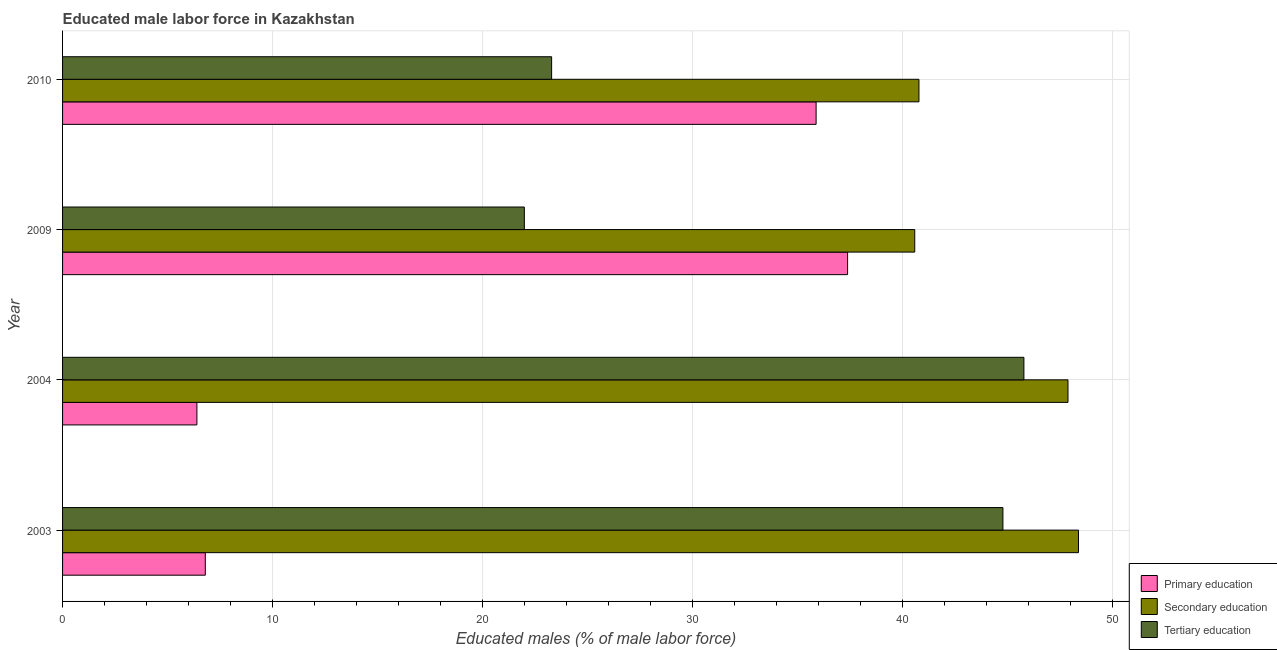How many different coloured bars are there?
Provide a short and direct response. 3. How many bars are there on the 3rd tick from the top?
Your response must be concise. 3. What is the label of the 4th group of bars from the top?
Make the answer very short. 2003. In how many cases, is the number of bars for a given year not equal to the number of legend labels?
Provide a short and direct response. 0. What is the percentage of male labor force who received secondary education in 2009?
Provide a short and direct response. 40.6. Across all years, what is the maximum percentage of male labor force who received secondary education?
Provide a short and direct response. 48.4. Across all years, what is the minimum percentage of male labor force who received primary education?
Offer a terse response. 6.4. In which year was the percentage of male labor force who received secondary education maximum?
Provide a succinct answer. 2003. What is the total percentage of male labor force who received tertiary education in the graph?
Offer a terse response. 135.9. What is the difference between the percentage of male labor force who received primary education in 2009 and that in 2010?
Make the answer very short. 1.5. What is the difference between the percentage of male labor force who received secondary education in 2004 and the percentage of male labor force who received tertiary education in 2009?
Ensure brevity in your answer.  25.9. What is the average percentage of male labor force who received secondary education per year?
Offer a terse response. 44.42. In the year 2009, what is the difference between the percentage of male labor force who received tertiary education and percentage of male labor force who received secondary education?
Keep it short and to the point. -18.6. In how many years, is the percentage of male labor force who received primary education greater than 8 %?
Offer a very short reply. 2. What is the ratio of the percentage of male labor force who received secondary education in 2004 to that in 2009?
Your answer should be very brief. 1.18. Is the percentage of male labor force who received secondary education in 2004 less than that in 2010?
Make the answer very short. No. What is the difference between the highest and the second highest percentage of male labor force who received secondary education?
Give a very brief answer. 0.5. What is the difference between the highest and the lowest percentage of male labor force who received tertiary education?
Your response must be concise. 23.8. What does the 2nd bar from the top in 2010 represents?
Provide a short and direct response. Secondary education. What does the 2nd bar from the bottom in 2004 represents?
Make the answer very short. Secondary education. Is it the case that in every year, the sum of the percentage of male labor force who received primary education and percentage of male labor force who received secondary education is greater than the percentage of male labor force who received tertiary education?
Provide a succinct answer. Yes. How many bars are there?
Offer a very short reply. 12. Are the values on the major ticks of X-axis written in scientific E-notation?
Your response must be concise. No. Where does the legend appear in the graph?
Provide a short and direct response. Bottom right. What is the title of the graph?
Keep it short and to the point. Educated male labor force in Kazakhstan. Does "Taxes on goods and services" appear as one of the legend labels in the graph?
Ensure brevity in your answer.  No. What is the label or title of the X-axis?
Your answer should be compact. Educated males (% of male labor force). What is the label or title of the Y-axis?
Your answer should be compact. Year. What is the Educated males (% of male labor force) in Primary education in 2003?
Offer a very short reply. 6.8. What is the Educated males (% of male labor force) of Secondary education in 2003?
Your answer should be compact. 48.4. What is the Educated males (% of male labor force) of Tertiary education in 2003?
Provide a short and direct response. 44.8. What is the Educated males (% of male labor force) of Primary education in 2004?
Keep it short and to the point. 6.4. What is the Educated males (% of male labor force) of Secondary education in 2004?
Offer a very short reply. 47.9. What is the Educated males (% of male labor force) of Tertiary education in 2004?
Make the answer very short. 45.8. What is the Educated males (% of male labor force) in Primary education in 2009?
Provide a succinct answer. 37.4. What is the Educated males (% of male labor force) of Secondary education in 2009?
Provide a succinct answer. 40.6. What is the Educated males (% of male labor force) of Tertiary education in 2009?
Provide a succinct answer. 22. What is the Educated males (% of male labor force) in Primary education in 2010?
Ensure brevity in your answer.  35.9. What is the Educated males (% of male labor force) in Secondary education in 2010?
Make the answer very short. 40.8. What is the Educated males (% of male labor force) in Tertiary education in 2010?
Give a very brief answer. 23.3. Across all years, what is the maximum Educated males (% of male labor force) of Primary education?
Provide a short and direct response. 37.4. Across all years, what is the maximum Educated males (% of male labor force) of Secondary education?
Offer a very short reply. 48.4. Across all years, what is the maximum Educated males (% of male labor force) in Tertiary education?
Your response must be concise. 45.8. Across all years, what is the minimum Educated males (% of male labor force) of Primary education?
Your answer should be very brief. 6.4. Across all years, what is the minimum Educated males (% of male labor force) of Secondary education?
Provide a succinct answer. 40.6. Across all years, what is the minimum Educated males (% of male labor force) in Tertiary education?
Provide a succinct answer. 22. What is the total Educated males (% of male labor force) of Primary education in the graph?
Provide a succinct answer. 86.5. What is the total Educated males (% of male labor force) of Secondary education in the graph?
Your response must be concise. 177.7. What is the total Educated males (% of male labor force) of Tertiary education in the graph?
Ensure brevity in your answer.  135.9. What is the difference between the Educated males (% of male labor force) in Secondary education in 2003 and that in 2004?
Your answer should be compact. 0.5. What is the difference between the Educated males (% of male labor force) in Tertiary education in 2003 and that in 2004?
Your answer should be very brief. -1. What is the difference between the Educated males (% of male labor force) in Primary education in 2003 and that in 2009?
Give a very brief answer. -30.6. What is the difference between the Educated males (% of male labor force) in Tertiary education in 2003 and that in 2009?
Your answer should be compact. 22.8. What is the difference between the Educated males (% of male labor force) in Primary education in 2003 and that in 2010?
Provide a short and direct response. -29.1. What is the difference between the Educated males (% of male labor force) of Tertiary education in 2003 and that in 2010?
Your answer should be very brief. 21.5. What is the difference between the Educated males (% of male labor force) in Primary education in 2004 and that in 2009?
Ensure brevity in your answer.  -31. What is the difference between the Educated males (% of male labor force) of Tertiary education in 2004 and that in 2009?
Ensure brevity in your answer.  23.8. What is the difference between the Educated males (% of male labor force) in Primary education in 2004 and that in 2010?
Make the answer very short. -29.5. What is the difference between the Educated males (% of male labor force) of Secondary education in 2004 and that in 2010?
Your answer should be very brief. 7.1. What is the difference between the Educated males (% of male labor force) of Tertiary education in 2009 and that in 2010?
Ensure brevity in your answer.  -1.3. What is the difference between the Educated males (% of male labor force) of Primary education in 2003 and the Educated males (% of male labor force) of Secondary education in 2004?
Give a very brief answer. -41.1. What is the difference between the Educated males (% of male labor force) of Primary education in 2003 and the Educated males (% of male labor force) of Tertiary education in 2004?
Provide a short and direct response. -39. What is the difference between the Educated males (% of male labor force) in Primary education in 2003 and the Educated males (% of male labor force) in Secondary education in 2009?
Make the answer very short. -33.8. What is the difference between the Educated males (% of male labor force) in Primary education in 2003 and the Educated males (% of male labor force) in Tertiary education in 2009?
Make the answer very short. -15.2. What is the difference between the Educated males (% of male labor force) of Secondary education in 2003 and the Educated males (% of male labor force) of Tertiary education in 2009?
Provide a short and direct response. 26.4. What is the difference between the Educated males (% of male labor force) of Primary education in 2003 and the Educated males (% of male labor force) of Secondary education in 2010?
Ensure brevity in your answer.  -34. What is the difference between the Educated males (% of male labor force) in Primary education in 2003 and the Educated males (% of male labor force) in Tertiary education in 2010?
Provide a short and direct response. -16.5. What is the difference between the Educated males (% of male labor force) in Secondary education in 2003 and the Educated males (% of male labor force) in Tertiary education in 2010?
Your response must be concise. 25.1. What is the difference between the Educated males (% of male labor force) in Primary education in 2004 and the Educated males (% of male labor force) in Secondary education in 2009?
Ensure brevity in your answer.  -34.2. What is the difference between the Educated males (% of male labor force) in Primary education in 2004 and the Educated males (% of male labor force) in Tertiary education in 2009?
Your answer should be compact. -15.6. What is the difference between the Educated males (% of male labor force) in Secondary education in 2004 and the Educated males (% of male labor force) in Tertiary education in 2009?
Keep it short and to the point. 25.9. What is the difference between the Educated males (% of male labor force) of Primary education in 2004 and the Educated males (% of male labor force) of Secondary education in 2010?
Offer a terse response. -34.4. What is the difference between the Educated males (% of male labor force) of Primary education in 2004 and the Educated males (% of male labor force) of Tertiary education in 2010?
Your answer should be very brief. -16.9. What is the difference between the Educated males (% of male labor force) in Secondary education in 2004 and the Educated males (% of male labor force) in Tertiary education in 2010?
Make the answer very short. 24.6. What is the difference between the Educated males (% of male labor force) in Primary education in 2009 and the Educated males (% of male labor force) in Secondary education in 2010?
Offer a very short reply. -3.4. What is the difference between the Educated males (% of male labor force) of Secondary education in 2009 and the Educated males (% of male labor force) of Tertiary education in 2010?
Provide a short and direct response. 17.3. What is the average Educated males (% of male labor force) of Primary education per year?
Provide a short and direct response. 21.62. What is the average Educated males (% of male labor force) in Secondary education per year?
Make the answer very short. 44.42. What is the average Educated males (% of male labor force) of Tertiary education per year?
Your answer should be compact. 33.98. In the year 2003, what is the difference between the Educated males (% of male labor force) of Primary education and Educated males (% of male labor force) of Secondary education?
Your answer should be very brief. -41.6. In the year 2003, what is the difference between the Educated males (% of male labor force) in Primary education and Educated males (% of male labor force) in Tertiary education?
Give a very brief answer. -38. In the year 2004, what is the difference between the Educated males (% of male labor force) in Primary education and Educated males (% of male labor force) in Secondary education?
Keep it short and to the point. -41.5. In the year 2004, what is the difference between the Educated males (% of male labor force) in Primary education and Educated males (% of male labor force) in Tertiary education?
Keep it short and to the point. -39.4. In the year 2004, what is the difference between the Educated males (% of male labor force) in Secondary education and Educated males (% of male labor force) in Tertiary education?
Offer a very short reply. 2.1. In the year 2009, what is the difference between the Educated males (% of male labor force) of Primary education and Educated males (% of male labor force) of Secondary education?
Make the answer very short. -3.2. In the year 2009, what is the difference between the Educated males (% of male labor force) in Primary education and Educated males (% of male labor force) in Tertiary education?
Ensure brevity in your answer.  15.4. In the year 2010, what is the difference between the Educated males (% of male labor force) in Primary education and Educated males (% of male labor force) in Secondary education?
Keep it short and to the point. -4.9. What is the ratio of the Educated males (% of male labor force) in Secondary education in 2003 to that in 2004?
Offer a terse response. 1.01. What is the ratio of the Educated males (% of male labor force) in Tertiary education in 2003 to that in 2004?
Provide a short and direct response. 0.98. What is the ratio of the Educated males (% of male labor force) of Primary education in 2003 to that in 2009?
Provide a short and direct response. 0.18. What is the ratio of the Educated males (% of male labor force) of Secondary education in 2003 to that in 2009?
Offer a terse response. 1.19. What is the ratio of the Educated males (% of male labor force) in Tertiary education in 2003 to that in 2009?
Your answer should be compact. 2.04. What is the ratio of the Educated males (% of male labor force) of Primary education in 2003 to that in 2010?
Offer a very short reply. 0.19. What is the ratio of the Educated males (% of male labor force) in Secondary education in 2003 to that in 2010?
Provide a succinct answer. 1.19. What is the ratio of the Educated males (% of male labor force) of Tertiary education in 2003 to that in 2010?
Your answer should be compact. 1.92. What is the ratio of the Educated males (% of male labor force) in Primary education in 2004 to that in 2009?
Provide a short and direct response. 0.17. What is the ratio of the Educated males (% of male labor force) in Secondary education in 2004 to that in 2009?
Make the answer very short. 1.18. What is the ratio of the Educated males (% of male labor force) in Tertiary education in 2004 to that in 2009?
Keep it short and to the point. 2.08. What is the ratio of the Educated males (% of male labor force) in Primary education in 2004 to that in 2010?
Ensure brevity in your answer.  0.18. What is the ratio of the Educated males (% of male labor force) of Secondary education in 2004 to that in 2010?
Your answer should be compact. 1.17. What is the ratio of the Educated males (% of male labor force) in Tertiary education in 2004 to that in 2010?
Offer a very short reply. 1.97. What is the ratio of the Educated males (% of male labor force) of Primary education in 2009 to that in 2010?
Offer a terse response. 1.04. What is the ratio of the Educated males (% of male labor force) of Tertiary education in 2009 to that in 2010?
Ensure brevity in your answer.  0.94. What is the difference between the highest and the second highest Educated males (% of male labor force) in Primary education?
Your response must be concise. 1.5. What is the difference between the highest and the second highest Educated males (% of male labor force) in Secondary education?
Your answer should be compact. 0.5. What is the difference between the highest and the second highest Educated males (% of male labor force) of Tertiary education?
Your answer should be compact. 1. What is the difference between the highest and the lowest Educated males (% of male labor force) in Secondary education?
Make the answer very short. 7.8. What is the difference between the highest and the lowest Educated males (% of male labor force) of Tertiary education?
Provide a short and direct response. 23.8. 